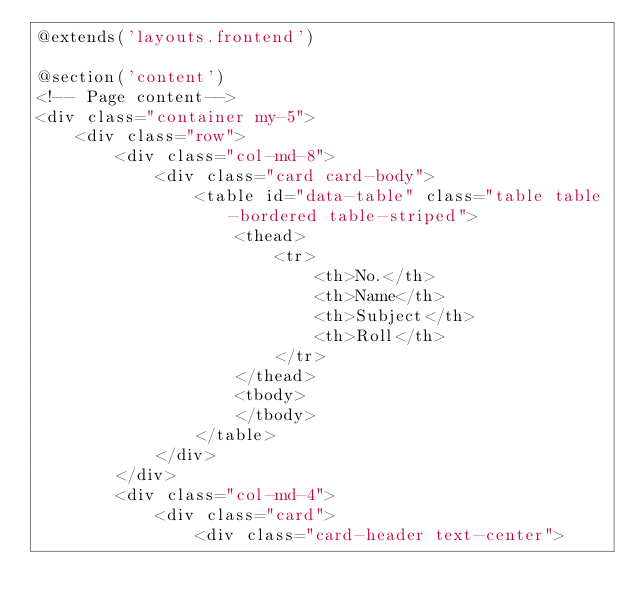<code> <loc_0><loc_0><loc_500><loc_500><_PHP_>@extends('layouts.frontend')

@section('content')
<!-- Page content-->
<div class="container my-5">
    <div class="row">
        <div class="col-md-8">
            <div class="card card-body">
                <table id="data-table" class="table table-bordered table-striped">
                    <thead>
                        <tr>
                            <th>No.</th>
                            <th>Name</th>
                            <th>Subject</th>
                            <th>Roll</th>
                        </tr>
                    </thead>
                    <tbody>
                    </tbody>
                </table>
            </div>
        </div>
        <div class="col-md-4">
            <div class="card">
                <div class="card-header text-center"></code> 